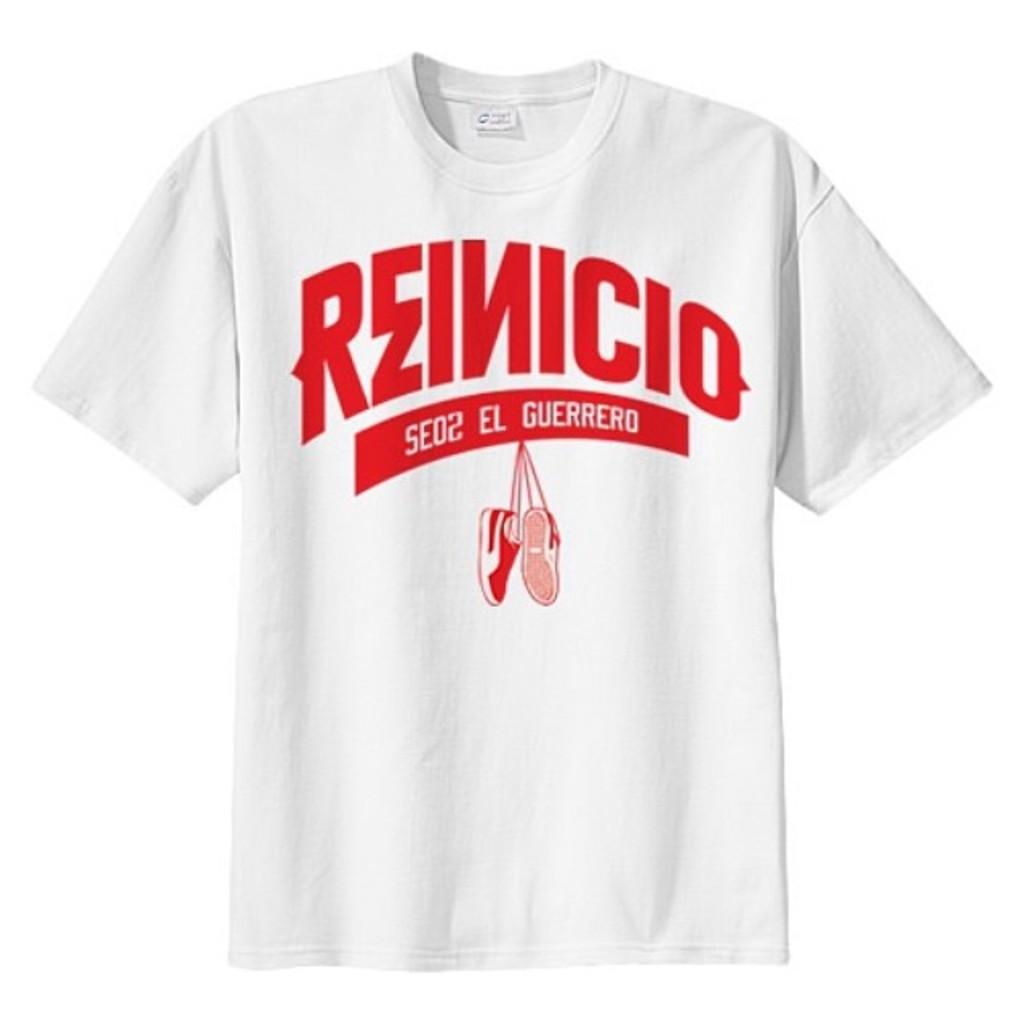<image>
Offer a succinct explanation of the picture presented. A white tshirt with the text reinicio el guerrero on the center of it in red. 